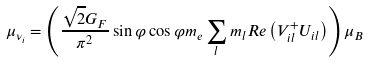<formula> <loc_0><loc_0><loc_500><loc_500>\mu _ { \nu _ { i } } = \left ( \frac { \sqrt { 2 } G _ { F } } { \pi ^ { 2 } } \sin \varphi \cos \varphi m _ { e } \sum _ { l } m _ { l } R e \left ( V _ { i l } ^ { + } U _ { i l } \right ) \right ) \mu _ { B }</formula> 